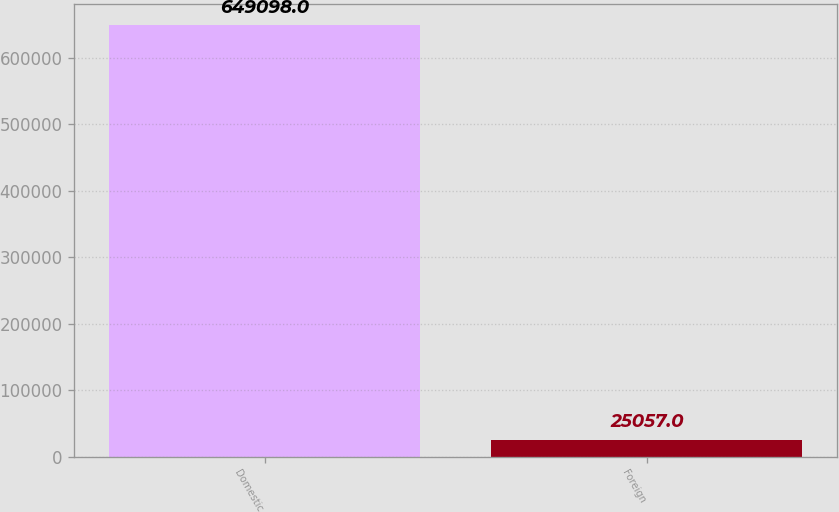<chart> <loc_0><loc_0><loc_500><loc_500><bar_chart><fcel>Domestic<fcel>Foreign<nl><fcel>649098<fcel>25057<nl></chart> 